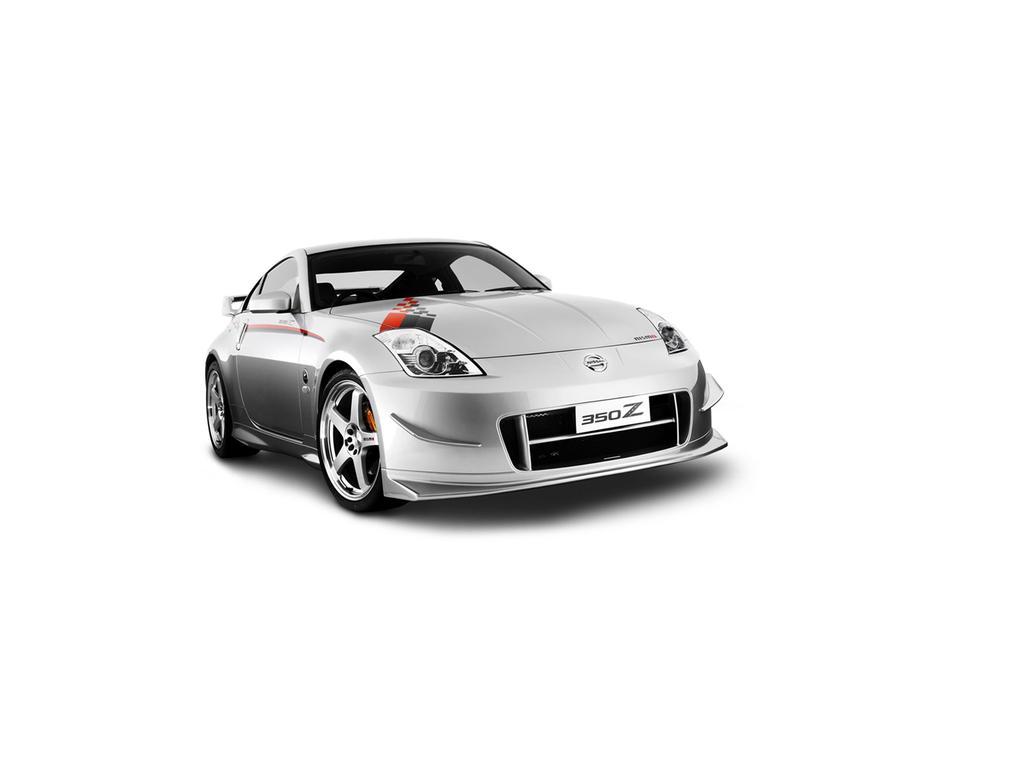In one or two sentences, can you explain what this image depicts? In this picture there is a car in the center of the image. 